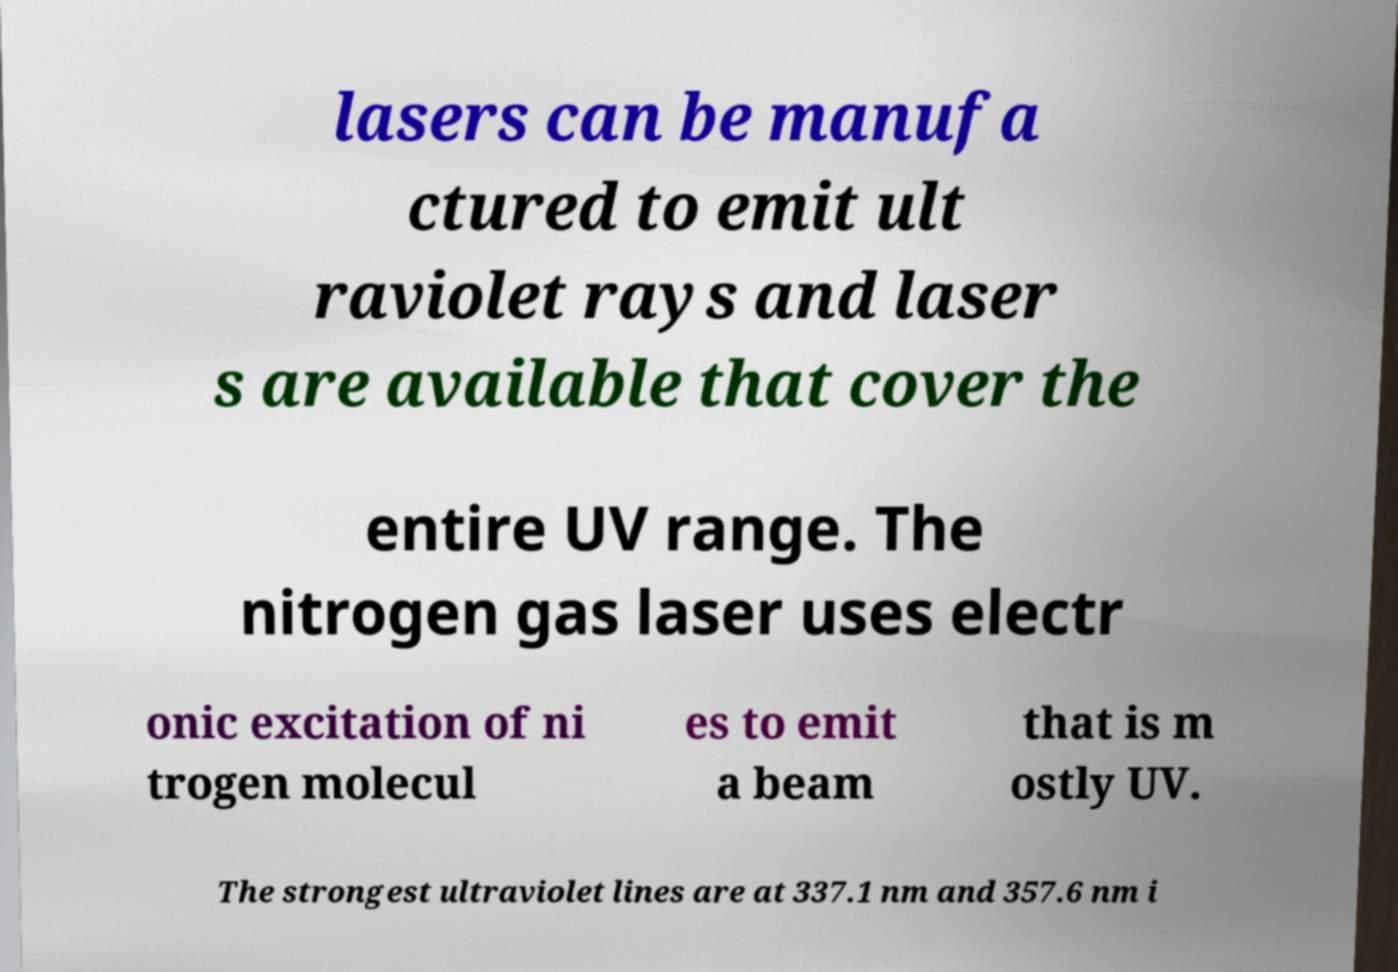For documentation purposes, I need the text within this image transcribed. Could you provide that? lasers can be manufa ctured to emit ult raviolet rays and laser s are available that cover the entire UV range. The nitrogen gas laser uses electr onic excitation of ni trogen molecul es to emit a beam that is m ostly UV. The strongest ultraviolet lines are at 337.1 nm and 357.6 nm i 